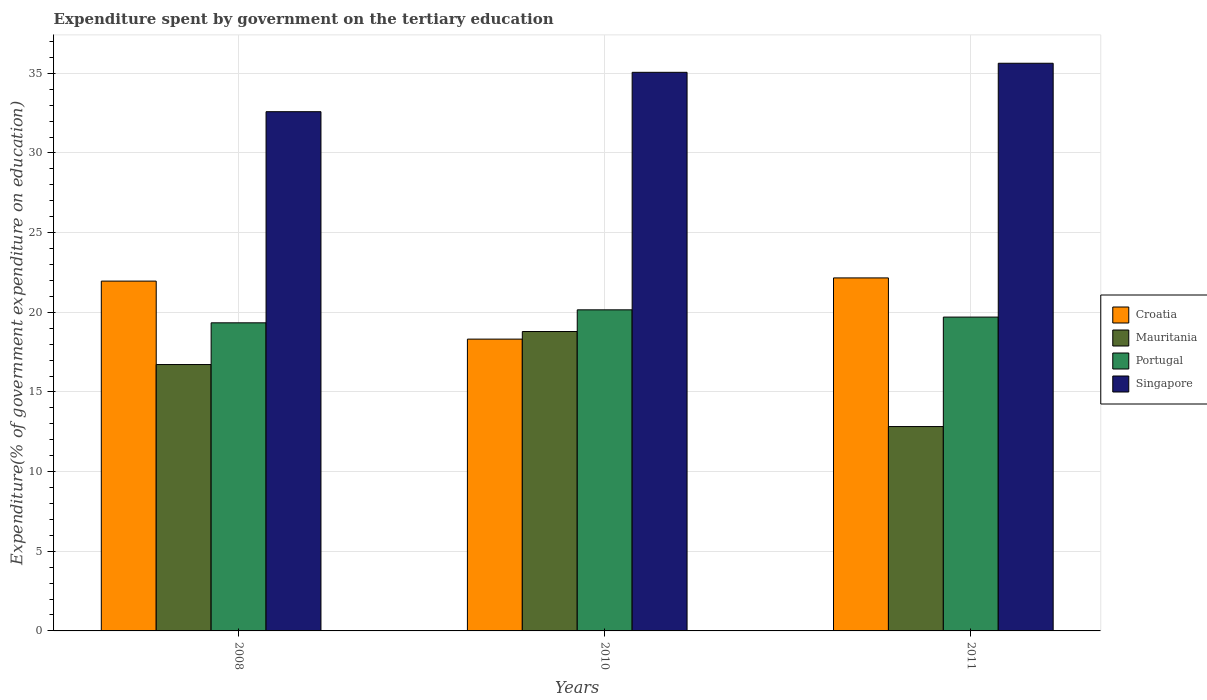How many groups of bars are there?
Keep it short and to the point. 3. Are the number of bars per tick equal to the number of legend labels?
Give a very brief answer. Yes. Are the number of bars on each tick of the X-axis equal?
Offer a terse response. Yes. How many bars are there on the 3rd tick from the left?
Your answer should be very brief. 4. What is the label of the 2nd group of bars from the left?
Keep it short and to the point. 2010. What is the expenditure spent by government on the tertiary education in Mauritania in 2008?
Offer a very short reply. 16.72. Across all years, what is the maximum expenditure spent by government on the tertiary education in Mauritania?
Offer a terse response. 18.79. Across all years, what is the minimum expenditure spent by government on the tertiary education in Croatia?
Ensure brevity in your answer.  18.32. In which year was the expenditure spent by government on the tertiary education in Portugal maximum?
Offer a terse response. 2010. What is the total expenditure spent by government on the tertiary education in Mauritania in the graph?
Keep it short and to the point. 48.34. What is the difference between the expenditure spent by government on the tertiary education in Croatia in 2008 and that in 2011?
Provide a short and direct response. -0.2. What is the difference between the expenditure spent by government on the tertiary education in Portugal in 2008 and the expenditure spent by government on the tertiary education in Singapore in 2011?
Ensure brevity in your answer.  -16.29. What is the average expenditure spent by government on the tertiary education in Singapore per year?
Keep it short and to the point. 34.43. In the year 2011, what is the difference between the expenditure spent by government on the tertiary education in Croatia and expenditure spent by government on the tertiary education in Singapore?
Give a very brief answer. -13.47. In how many years, is the expenditure spent by government on the tertiary education in Mauritania greater than 34 %?
Your response must be concise. 0. What is the ratio of the expenditure spent by government on the tertiary education in Singapore in 2010 to that in 2011?
Offer a terse response. 0.98. What is the difference between the highest and the second highest expenditure spent by government on the tertiary education in Singapore?
Give a very brief answer. 0.57. What is the difference between the highest and the lowest expenditure spent by government on the tertiary education in Croatia?
Your answer should be compact. 3.84. In how many years, is the expenditure spent by government on the tertiary education in Croatia greater than the average expenditure spent by government on the tertiary education in Croatia taken over all years?
Provide a succinct answer. 2. Is it the case that in every year, the sum of the expenditure spent by government on the tertiary education in Croatia and expenditure spent by government on the tertiary education in Mauritania is greater than the sum of expenditure spent by government on the tertiary education in Portugal and expenditure spent by government on the tertiary education in Singapore?
Keep it short and to the point. No. What does the 3rd bar from the right in 2011 represents?
Offer a terse response. Mauritania. What is the difference between two consecutive major ticks on the Y-axis?
Keep it short and to the point. 5. Are the values on the major ticks of Y-axis written in scientific E-notation?
Your answer should be compact. No. Does the graph contain grids?
Your answer should be very brief. Yes. Where does the legend appear in the graph?
Offer a terse response. Center right. How many legend labels are there?
Your response must be concise. 4. How are the legend labels stacked?
Your answer should be very brief. Vertical. What is the title of the graph?
Provide a short and direct response. Expenditure spent by government on the tertiary education. Does "Mexico" appear as one of the legend labels in the graph?
Your answer should be compact. No. What is the label or title of the Y-axis?
Make the answer very short. Expenditure(% of government expenditure on education). What is the Expenditure(% of government expenditure on education) of Croatia in 2008?
Keep it short and to the point. 21.96. What is the Expenditure(% of government expenditure on education) in Mauritania in 2008?
Your answer should be compact. 16.72. What is the Expenditure(% of government expenditure on education) in Portugal in 2008?
Ensure brevity in your answer.  19.34. What is the Expenditure(% of government expenditure on education) in Singapore in 2008?
Your answer should be compact. 32.59. What is the Expenditure(% of government expenditure on education) in Croatia in 2010?
Make the answer very short. 18.32. What is the Expenditure(% of government expenditure on education) in Mauritania in 2010?
Your answer should be very brief. 18.79. What is the Expenditure(% of government expenditure on education) of Portugal in 2010?
Your response must be concise. 20.15. What is the Expenditure(% of government expenditure on education) in Singapore in 2010?
Give a very brief answer. 35.06. What is the Expenditure(% of government expenditure on education) of Croatia in 2011?
Ensure brevity in your answer.  22.16. What is the Expenditure(% of government expenditure on education) of Mauritania in 2011?
Make the answer very short. 12.83. What is the Expenditure(% of government expenditure on education) in Portugal in 2011?
Your answer should be compact. 19.7. What is the Expenditure(% of government expenditure on education) in Singapore in 2011?
Your answer should be very brief. 35.63. Across all years, what is the maximum Expenditure(% of government expenditure on education) of Croatia?
Your answer should be compact. 22.16. Across all years, what is the maximum Expenditure(% of government expenditure on education) in Mauritania?
Your response must be concise. 18.79. Across all years, what is the maximum Expenditure(% of government expenditure on education) in Portugal?
Your answer should be very brief. 20.15. Across all years, what is the maximum Expenditure(% of government expenditure on education) of Singapore?
Make the answer very short. 35.63. Across all years, what is the minimum Expenditure(% of government expenditure on education) in Croatia?
Provide a succinct answer. 18.32. Across all years, what is the minimum Expenditure(% of government expenditure on education) in Mauritania?
Your answer should be very brief. 12.83. Across all years, what is the minimum Expenditure(% of government expenditure on education) of Portugal?
Your answer should be very brief. 19.34. Across all years, what is the minimum Expenditure(% of government expenditure on education) in Singapore?
Your answer should be very brief. 32.59. What is the total Expenditure(% of government expenditure on education) of Croatia in the graph?
Your answer should be very brief. 62.43. What is the total Expenditure(% of government expenditure on education) in Mauritania in the graph?
Ensure brevity in your answer.  48.34. What is the total Expenditure(% of government expenditure on education) of Portugal in the graph?
Provide a succinct answer. 59.19. What is the total Expenditure(% of government expenditure on education) of Singapore in the graph?
Offer a very short reply. 103.28. What is the difference between the Expenditure(% of government expenditure on education) of Croatia in 2008 and that in 2010?
Give a very brief answer. 3.64. What is the difference between the Expenditure(% of government expenditure on education) in Mauritania in 2008 and that in 2010?
Ensure brevity in your answer.  -2.07. What is the difference between the Expenditure(% of government expenditure on education) of Portugal in 2008 and that in 2010?
Your answer should be compact. -0.82. What is the difference between the Expenditure(% of government expenditure on education) in Singapore in 2008 and that in 2010?
Offer a very short reply. -2.47. What is the difference between the Expenditure(% of government expenditure on education) in Croatia in 2008 and that in 2011?
Your response must be concise. -0.2. What is the difference between the Expenditure(% of government expenditure on education) in Mauritania in 2008 and that in 2011?
Keep it short and to the point. 3.89. What is the difference between the Expenditure(% of government expenditure on education) of Portugal in 2008 and that in 2011?
Your answer should be very brief. -0.36. What is the difference between the Expenditure(% of government expenditure on education) of Singapore in 2008 and that in 2011?
Provide a succinct answer. -3.04. What is the difference between the Expenditure(% of government expenditure on education) of Croatia in 2010 and that in 2011?
Ensure brevity in your answer.  -3.84. What is the difference between the Expenditure(% of government expenditure on education) in Mauritania in 2010 and that in 2011?
Keep it short and to the point. 5.96. What is the difference between the Expenditure(% of government expenditure on education) in Portugal in 2010 and that in 2011?
Your response must be concise. 0.46. What is the difference between the Expenditure(% of government expenditure on education) in Singapore in 2010 and that in 2011?
Keep it short and to the point. -0.57. What is the difference between the Expenditure(% of government expenditure on education) in Croatia in 2008 and the Expenditure(% of government expenditure on education) in Mauritania in 2010?
Keep it short and to the point. 3.17. What is the difference between the Expenditure(% of government expenditure on education) in Croatia in 2008 and the Expenditure(% of government expenditure on education) in Portugal in 2010?
Keep it short and to the point. 1.8. What is the difference between the Expenditure(% of government expenditure on education) of Croatia in 2008 and the Expenditure(% of government expenditure on education) of Singapore in 2010?
Provide a short and direct response. -13.1. What is the difference between the Expenditure(% of government expenditure on education) in Mauritania in 2008 and the Expenditure(% of government expenditure on education) in Portugal in 2010?
Provide a succinct answer. -3.43. What is the difference between the Expenditure(% of government expenditure on education) in Mauritania in 2008 and the Expenditure(% of government expenditure on education) in Singapore in 2010?
Ensure brevity in your answer.  -18.34. What is the difference between the Expenditure(% of government expenditure on education) in Portugal in 2008 and the Expenditure(% of government expenditure on education) in Singapore in 2010?
Provide a short and direct response. -15.72. What is the difference between the Expenditure(% of government expenditure on education) of Croatia in 2008 and the Expenditure(% of government expenditure on education) of Mauritania in 2011?
Give a very brief answer. 9.13. What is the difference between the Expenditure(% of government expenditure on education) of Croatia in 2008 and the Expenditure(% of government expenditure on education) of Portugal in 2011?
Your answer should be compact. 2.26. What is the difference between the Expenditure(% of government expenditure on education) of Croatia in 2008 and the Expenditure(% of government expenditure on education) of Singapore in 2011?
Your answer should be very brief. -13.67. What is the difference between the Expenditure(% of government expenditure on education) in Mauritania in 2008 and the Expenditure(% of government expenditure on education) in Portugal in 2011?
Keep it short and to the point. -2.98. What is the difference between the Expenditure(% of government expenditure on education) in Mauritania in 2008 and the Expenditure(% of government expenditure on education) in Singapore in 2011?
Your answer should be compact. -18.91. What is the difference between the Expenditure(% of government expenditure on education) in Portugal in 2008 and the Expenditure(% of government expenditure on education) in Singapore in 2011?
Offer a terse response. -16.29. What is the difference between the Expenditure(% of government expenditure on education) in Croatia in 2010 and the Expenditure(% of government expenditure on education) in Mauritania in 2011?
Give a very brief answer. 5.49. What is the difference between the Expenditure(% of government expenditure on education) of Croatia in 2010 and the Expenditure(% of government expenditure on education) of Portugal in 2011?
Ensure brevity in your answer.  -1.38. What is the difference between the Expenditure(% of government expenditure on education) of Croatia in 2010 and the Expenditure(% of government expenditure on education) of Singapore in 2011?
Give a very brief answer. -17.31. What is the difference between the Expenditure(% of government expenditure on education) of Mauritania in 2010 and the Expenditure(% of government expenditure on education) of Portugal in 2011?
Ensure brevity in your answer.  -0.91. What is the difference between the Expenditure(% of government expenditure on education) in Mauritania in 2010 and the Expenditure(% of government expenditure on education) in Singapore in 2011?
Keep it short and to the point. -16.84. What is the difference between the Expenditure(% of government expenditure on education) in Portugal in 2010 and the Expenditure(% of government expenditure on education) in Singapore in 2011?
Give a very brief answer. -15.48. What is the average Expenditure(% of government expenditure on education) of Croatia per year?
Keep it short and to the point. 20.81. What is the average Expenditure(% of government expenditure on education) of Mauritania per year?
Your answer should be very brief. 16.11. What is the average Expenditure(% of government expenditure on education) of Portugal per year?
Give a very brief answer. 19.73. What is the average Expenditure(% of government expenditure on education) of Singapore per year?
Offer a very short reply. 34.43. In the year 2008, what is the difference between the Expenditure(% of government expenditure on education) in Croatia and Expenditure(% of government expenditure on education) in Mauritania?
Offer a very short reply. 5.24. In the year 2008, what is the difference between the Expenditure(% of government expenditure on education) of Croatia and Expenditure(% of government expenditure on education) of Portugal?
Your response must be concise. 2.62. In the year 2008, what is the difference between the Expenditure(% of government expenditure on education) of Croatia and Expenditure(% of government expenditure on education) of Singapore?
Your response must be concise. -10.63. In the year 2008, what is the difference between the Expenditure(% of government expenditure on education) in Mauritania and Expenditure(% of government expenditure on education) in Portugal?
Ensure brevity in your answer.  -2.62. In the year 2008, what is the difference between the Expenditure(% of government expenditure on education) in Mauritania and Expenditure(% of government expenditure on education) in Singapore?
Make the answer very short. -15.87. In the year 2008, what is the difference between the Expenditure(% of government expenditure on education) in Portugal and Expenditure(% of government expenditure on education) in Singapore?
Offer a terse response. -13.25. In the year 2010, what is the difference between the Expenditure(% of government expenditure on education) in Croatia and Expenditure(% of government expenditure on education) in Mauritania?
Give a very brief answer. -0.48. In the year 2010, what is the difference between the Expenditure(% of government expenditure on education) of Croatia and Expenditure(% of government expenditure on education) of Portugal?
Provide a succinct answer. -1.84. In the year 2010, what is the difference between the Expenditure(% of government expenditure on education) in Croatia and Expenditure(% of government expenditure on education) in Singapore?
Provide a short and direct response. -16.75. In the year 2010, what is the difference between the Expenditure(% of government expenditure on education) in Mauritania and Expenditure(% of government expenditure on education) in Portugal?
Offer a very short reply. -1.36. In the year 2010, what is the difference between the Expenditure(% of government expenditure on education) of Mauritania and Expenditure(% of government expenditure on education) of Singapore?
Provide a succinct answer. -16.27. In the year 2010, what is the difference between the Expenditure(% of government expenditure on education) of Portugal and Expenditure(% of government expenditure on education) of Singapore?
Your answer should be compact. -14.91. In the year 2011, what is the difference between the Expenditure(% of government expenditure on education) of Croatia and Expenditure(% of government expenditure on education) of Mauritania?
Offer a terse response. 9.33. In the year 2011, what is the difference between the Expenditure(% of government expenditure on education) of Croatia and Expenditure(% of government expenditure on education) of Portugal?
Give a very brief answer. 2.46. In the year 2011, what is the difference between the Expenditure(% of government expenditure on education) in Croatia and Expenditure(% of government expenditure on education) in Singapore?
Make the answer very short. -13.47. In the year 2011, what is the difference between the Expenditure(% of government expenditure on education) in Mauritania and Expenditure(% of government expenditure on education) in Portugal?
Offer a very short reply. -6.87. In the year 2011, what is the difference between the Expenditure(% of government expenditure on education) in Mauritania and Expenditure(% of government expenditure on education) in Singapore?
Your answer should be very brief. -22.8. In the year 2011, what is the difference between the Expenditure(% of government expenditure on education) of Portugal and Expenditure(% of government expenditure on education) of Singapore?
Your response must be concise. -15.93. What is the ratio of the Expenditure(% of government expenditure on education) in Croatia in 2008 to that in 2010?
Offer a very short reply. 1.2. What is the ratio of the Expenditure(% of government expenditure on education) of Mauritania in 2008 to that in 2010?
Provide a succinct answer. 0.89. What is the ratio of the Expenditure(% of government expenditure on education) of Portugal in 2008 to that in 2010?
Your answer should be compact. 0.96. What is the ratio of the Expenditure(% of government expenditure on education) in Singapore in 2008 to that in 2010?
Your answer should be compact. 0.93. What is the ratio of the Expenditure(% of government expenditure on education) of Croatia in 2008 to that in 2011?
Your response must be concise. 0.99. What is the ratio of the Expenditure(% of government expenditure on education) of Mauritania in 2008 to that in 2011?
Keep it short and to the point. 1.3. What is the ratio of the Expenditure(% of government expenditure on education) of Portugal in 2008 to that in 2011?
Keep it short and to the point. 0.98. What is the ratio of the Expenditure(% of government expenditure on education) of Singapore in 2008 to that in 2011?
Your response must be concise. 0.91. What is the ratio of the Expenditure(% of government expenditure on education) in Croatia in 2010 to that in 2011?
Give a very brief answer. 0.83. What is the ratio of the Expenditure(% of government expenditure on education) in Mauritania in 2010 to that in 2011?
Provide a succinct answer. 1.47. What is the ratio of the Expenditure(% of government expenditure on education) in Portugal in 2010 to that in 2011?
Your answer should be very brief. 1.02. What is the difference between the highest and the second highest Expenditure(% of government expenditure on education) of Croatia?
Offer a very short reply. 0.2. What is the difference between the highest and the second highest Expenditure(% of government expenditure on education) of Mauritania?
Give a very brief answer. 2.07. What is the difference between the highest and the second highest Expenditure(% of government expenditure on education) of Portugal?
Ensure brevity in your answer.  0.46. What is the difference between the highest and the second highest Expenditure(% of government expenditure on education) in Singapore?
Make the answer very short. 0.57. What is the difference between the highest and the lowest Expenditure(% of government expenditure on education) of Croatia?
Provide a succinct answer. 3.84. What is the difference between the highest and the lowest Expenditure(% of government expenditure on education) in Mauritania?
Your answer should be very brief. 5.96. What is the difference between the highest and the lowest Expenditure(% of government expenditure on education) of Portugal?
Offer a terse response. 0.82. What is the difference between the highest and the lowest Expenditure(% of government expenditure on education) of Singapore?
Provide a succinct answer. 3.04. 